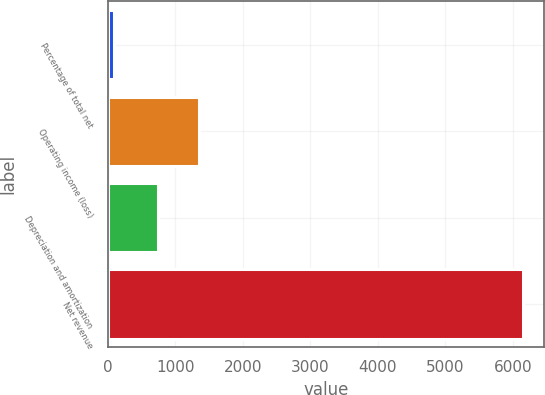Convert chart. <chart><loc_0><loc_0><loc_500><loc_500><bar_chart><fcel>Percentage of total net<fcel>Operating income (loss)<fcel>Depreciation and amortization<fcel>Net revenue<nl><fcel>100<fcel>1348<fcel>743<fcel>6150<nl></chart> 